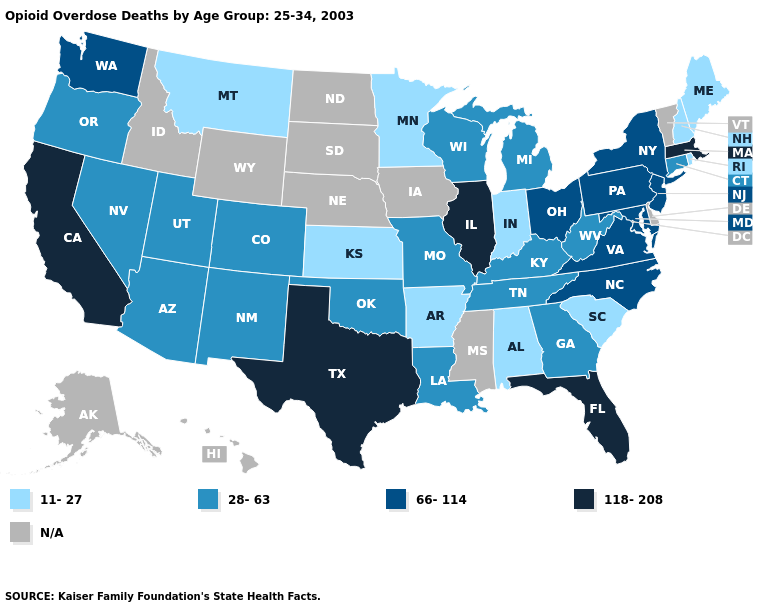Among the states that border North Carolina , does Tennessee have the lowest value?
Quick response, please. No. What is the value of Idaho?
Keep it brief. N/A. Among the states that border Virginia , which have the highest value?
Concise answer only. Maryland, North Carolina. Does Illinois have the highest value in the USA?
Short answer required. Yes. Which states have the lowest value in the USA?
Be succinct. Alabama, Arkansas, Indiana, Kansas, Maine, Minnesota, Montana, New Hampshire, Rhode Island, South Carolina. What is the value of Louisiana?
Answer briefly. 28-63. What is the lowest value in the MidWest?
Be succinct. 11-27. Among the states that border Utah , which have the highest value?
Give a very brief answer. Arizona, Colorado, Nevada, New Mexico. What is the value of Massachusetts?
Write a very short answer. 118-208. Name the states that have a value in the range 118-208?
Give a very brief answer. California, Florida, Illinois, Massachusetts, Texas. Does the map have missing data?
Give a very brief answer. Yes. What is the value of Ohio?
Write a very short answer. 66-114. How many symbols are there in the legend?
Keep it brief. 5. What is the value of Hawaii?
Give a very brief answer. N/A. How many symbols are there in the legend?
Keep it brief. 5. 